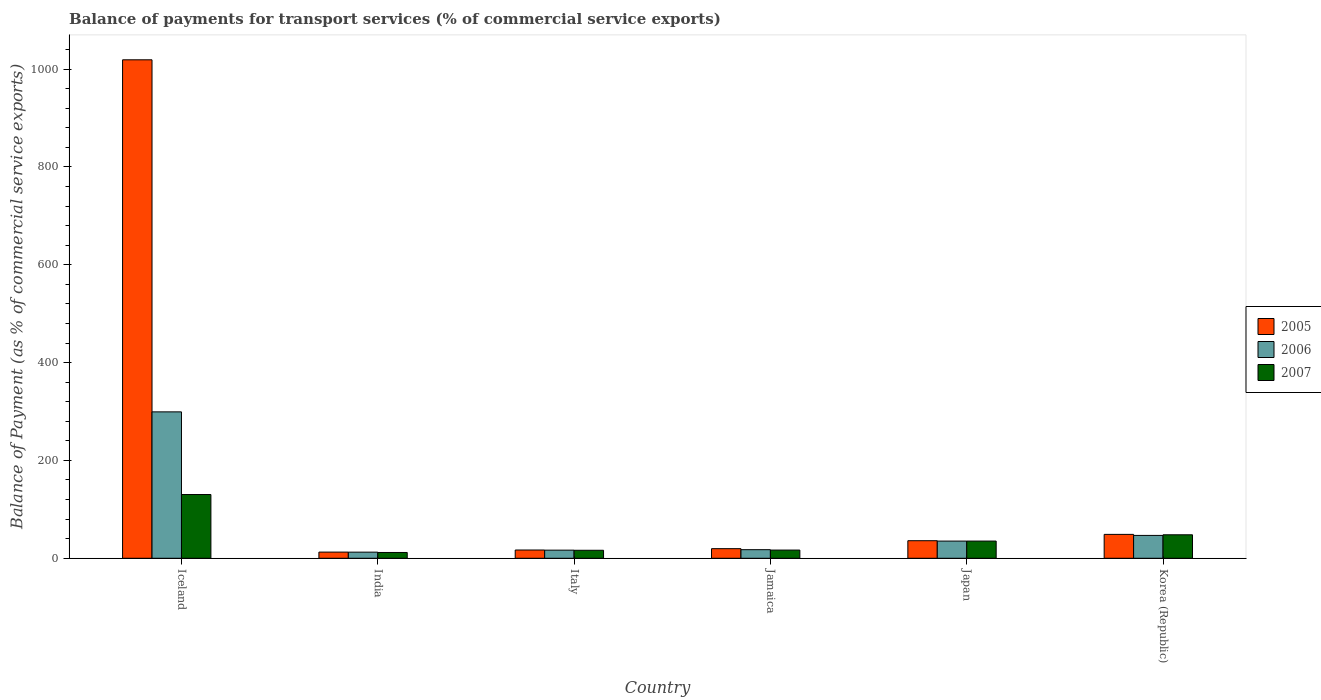How many different coloured bars are there?
Your answer should be very brief. 3. How many groups of bars are there?
Offer a terse response. 6. What is the balance of payments for transport services in 2005 in Japan?
Provide a short and direct response. 35.89. Across all countries, what is the maximum balance of payments for transport services in 2005?
Ensure brevity in your answer.  1018.95. Across all countries, what is the minimum balance of payments for transport services in 2007?
Provide a succinct answer. 11.84. In which country was the balance of payments for transport services in 2006 maximum?
Make the answer very short. Iceland. In which country was the balance of payments for transport services in 2005 minimum?
Give a very brief answer. India. What is the total balance of payments for transport services in 2005 in the graph?
Make the answer very short. 1152.83. What is the difference between the balance of payments for transport services in 2006 in India and that in Korea (Republic)?
Offer a terse response. -34.22. What is the difference between the balance of payments for transport services in 2006 in Jamaica and the balance of payments for transport services in 2005 in Korea (Republic)?
Keep it short and to the point. -31.27. What is the average balance of payments for transport services in 2007 per country?
Your answer should be very brief. 43.07. What is the difference between the balance of payments for transport services of/in 2006 and balance of payments for transport services of/in 2005 in Korea (Republic)?
Offer a very short reply. -2.11. In how many countries, is the balance of payments for transport services in 2007 greater than 880 %?
Your answer should be compact. 0. What is the ratio of the balance of payments for transport services in 2005 in Iceland to that in Korea (Republic)?
Ensure brevity in your answer.  20.86. What is the difference between the highest and the second highest balance of payments for transport services in 2005?
Provide a succinct answer. -970.12. What is the difference between the highest and the lowest balance of payments for transport services in 2007?
Your response must be concise. 118.48. In how many countries, is the balance of payments for transport services in 2006 greater than the average balance of payments for transport services in 2006 taken over all countries?
Ensure brevity in your answer.  1. Is it the case that in every country, the sum of the balance of payments for transport services in 2006 and balance of payments for transport services in 2005 is greater than the balance of payments for transport services in 2007?
Keep it short and to the point. Yes. What is the difference between two consecutive major ticks on the Y-axis?
Keep it short and to the point. 200. Are the values on the major ticks of Y-axis written in scientific E-notation?
Your answer should be very brief. No. Where does the legend appear in the graph?
Provide a short and direct response. Center right. What is the title of the graph?
Make the answer very short. Balance of payments for transport services (% of commercial service exports). Does "1969" appear as one of the legend labels in the graph?
Provide a short and direct response. No. What is the label or title of the X-axis?
Your answer should be compact. Country. What is the label or title of the Y-axis?
Ensure brevity in your answer.  Balance of Payment (as % of commercial service exports). What is the Balance of Payment (as % of commercial service exports) of 2005 in Iceland?
Your response must be concise. 1018.95. What is the Balance of Payment (as % of commercial service exports) in 2006 in Iceland?
Keep it short and to the point. 299.28. What is the Balance of Payment (as % of commercial service exports) in 2007 in Iceland?
Your response must be concise. 130.32. What is the Balance of Payment (as % of commercial service exports) in 2005 in India?
Provide a short and direct response. 12.61. What is the Balance of Payment (as % of commercial service exports) in 2006 in India?
Your answer should be very brief. 12.51. What is the Balance of Payment (as % of commercial service exports) of 2007 in India?
Your response must be concise. 11.84. What is the Balance of Payment (as % of commercial service exports) of 2005 in Italy?
Make the answer very short. 16.89. What is the Balance of Payment (as % of commercial service exports) of 2006 in Italy?
Offer a terse response. 16.59. What is the Balance of Payment (as % of commercial service exports) of 2007 in Italy?
Your response must be concise. 16.34. What is the Balance of Payment (as % of commercial service exports) of 2005 in Jamaica?
Keep it short and to the point. 19.65. What is the Balance of Payment (as % of commercial service exports) of 2006 in Jamaica?
Give a very brief answer. 17.56. What is the Balance of Payment (as % of commercial service exports) in 2007 in Jamaica?
Give a very brief answer. 16.75. What is the Balance of Payment (as % of commercial service exports) in 2005 in Japan?
Offer a terse response. 35.89. What is the Balance of Payment (as % of commercial service exports) of 2006 in Japan?
Keep it short and to the point. 35.12. What is the Balance of Payment (as % of commercial service exports) of 2007 in Japan?
Offer a very short reply. 35.16. What is the Balance of Payment (as % of commercial service exports) of 2005 in Korea (Republic)?
Your answer should be compact. 48.84. What is the Balance of Payment (as % of commercial service exports) in 2006 in Korea (Republic)?
Provide a succinct answer. 46.72. What is the Balance of Payment (as % of commercial service exports) in 2007 in Korea (Republic)?
Provide a succinct answer. 48.01. Across all countries, what is the maximum Balance of Payment (as % of commercial service exports) of 2005?
Keep it short and to the point. 1018.95. Across all countries, what is the maximum Balance of Payment (as % of commercial service exports) of 2006?
Ensure brevity in your answer.  299.28. Across all countries, what is the maximum Balance of Payment (as % of commercial service exports) in 2007?
Provide a succinct answer. 130.32. Across all countries, what is the minimum Balance of Payment (as % of commercial service exports) in 2005?
Your answer should be very brief. 12.61. Across all countries, what is the minimum Balance of Payment (as % of commercial service exports) of 2006?
Your answer should be very brief. 12.51. Across all countries, what is the minimum Balance of Payment (as % of commercial service exports) in 2007?
Give a very brief answer. 11.84. What is the total Balance of Payment (as % of commercial service exports) of 2005 in the graph?
Keep it short and to the point. 1152.83. What is the total Balance of Payment (as % of commercial service exports) of 2006 in the graph?
Provide a short and direct response. 427.78. What is the total Balance of Payment (as % of commercial service exports) of 2007 in the graph?
Provide a short and direct response. 258.42. What is the difference between the Balance of Payment (as % of commercial service exports) of 2005 in Iceland and that in India?
Ensure brevity in your answer.  1006.35. What is the difference between the Balance of Payment (as % of commercial service exports) in 2006 in Iceland and that in India?
Provide a succinct answer. 286.77. What is the difference between the Balance of Payment (as % of commercial service exports) in 2007 in Iceland and that in India?
Provide a short and direct response. 118.48. What is the difference between the Balance of Payment (as % of commercial service exports) in 2005 in Iceland and that in Italy?
Give a very brief answer. 1002.06. What is the difference between the Balance of Payment (as % of commercial service exports) of 2006 in Iceland and that in Italy?
Offer a terse response. 282.69. What is the difference between the Balance of Payment (as % of commercial service exports) in 2007 in Iceland and that in Italy?
Your response must be concise. 113.98. What is the difference between the Balance of Payment (as % of commercial service exports) in 2005 in Iceland and that in Jamaica?
Keep it short and to the point. 999.3. What is the difference between the Balance of Payment (as % of commercial service exports) of 2006 in Iceland and that in Jamaica?
Provide a succinct answer. 281.71. What is the difference between the Balance of Payment (as % of commercial service exports) in 2007 in Iceland and that in Jamaica?
Provide a succinct answer. 113.57. What is the difference between the Balance of Payment (as % of commercial service exports) in 2005 in Iceland and that in Japan?
Your answer should be compact. 983.07. What is the difference between the Balance of Payment (as % of commercial service exports) in 2006 in Iceland and that in Japan?
Your answer should be compact. 264.15. What is the difference between the Balance of Payment (as % of commercial service exports) of 2007 in Iceland and that in Japan?
Provide a short and direct response. 95.17. What is the difference between the Balance of Payment (as % of commercial service exports) of 2005 in Iceland and that in Korea (Republic)?
Keep it short and to the point. 970.12. What is the difference between the Balance of Payment (as % of commercial service exports) of 2006 in Iceland and that in Korea (Republic)?
Keep it short and to the point. 252.55. What is the difference between the Balance of Payment (as % of commercial service exports) in 2007 in Iceland and that in Korea (Republic)?
Keep it short and to the point. 82.31. What is the difference between the Balance of Payment (as % of commercial service exports) in 2005 in India and that in Italy?
Your response must be concise. -4.29. What is the difference between the Balance of Payment (as % of commercial service exports) of 2006 in India and that in Italy?
Provide a succinct answer. -4.08. What is the difference between the Balance of Payment (as % of commercial service exports) in 2007 in India and that in Italy?
Keep it short and to the point. -4.5. What is the difference between the Balance of Payment (as % of commercial service exports) of 2005 in India and that in Jamaica?
Keep it short and to the point. -7.04. What is the difference between the Balance of Payment (as % of commercial service exports) in 2006 in India and that in Jamaica?
Ensure brevity in your answer.  -5.05. What is the difference between the Balance of Payment (as % of commercial service exports) of 2007 in India and that in Jamaica?
Ensure brevity in your answer.  -4.91. What is the difference between the Balance of Payment (as % of commercial service exports) in 2005 in India and that in Japan?
Your answer should be very brief. -23.28. What is the difference between the Balance of Payment (as % of commercial service exports) of 2006 in India and that in Japan?
Offer a terse response. -22.61. What is the difference between the Balance of Payment (as % of commercial service exports) of 2007 in India and that in Japan?
Give a very brief answer. -23.32. What is the difference between the Balance of Payment (as % of commercial service exports) of 2005 in India and that in Korea (Republic)?
Offer a very short reply. -36.23. What is the difference between the Balance of Payment (as % of commercial service exports) of 2006 in India and that in Korea (Republic)?
Offer a very short reply. -34.22. What is the difference between the Balance of Payment (as % of commercial service exports) in 2007 in India and that in Korea (Republic)?
Your response must be concise. -36.17. What is the difference between the Balance of Payment (as % of commercial service exports) in 2005 in Italy and that in Jamaica?
Your answer should be very brief. -2.76. What is the difference between the Balance of Payment (as % of commercial service exports) of 2006 in Italy and that in Jamaica?
Provide a succinct answer. -0.97. What is the difference between the Balance of Payment (as % of commercial service exports) of 2007 in Italy and that in Jamaica?
Provide a succinct answer. -0.41. What is the difference between the Balance of Payment (as % of commercial service exports) of 2005 in Italy and that in Japan?
Ensure brevity in your answer.  -18.99. What is the difference between the Balance of Payment (as % of commercial service exports) of 2006 in Italy and that in Japan?
Offer a terse response. -18.53. What is the difference between the Balance of Payment (as % of commercial service exports) of 2007 in Italy and that in Japan?
Offer a terse response. -18.82. What is the difference between the Balance of Payment (as % of commercial service exports) in 2005 in Italy and that in Korea (Republic)?
Make the answer very short. -31.94. What is the difference between the Balance of Payment (as % of commercial service exports) of 2006 in Italy and that in Korea (Republic)?
Provide a succinct answer. -30.14. What is the difference between the Balance of Payment (as % of commercial service exports) of 2007 in Italy and that in Korea (Republic)?
Provide a succinct answer. -31.67. What is the difference between the Balance of Payment (as % of commercial service exports) of 2005 in Jamaica and that in Japan?
Your response must be concise. -16.24. What is the difference between the Balance of Payment (as % of commercial service exports) of 2006 in Jamaica and that in Japan?
Ensure brevity in your answer.  -17.56. What is the difference between the Balance of Payment (as % of commercial service exports) in 2007 in Jamaica and that in Japan?
Give a very brief answer. -18.41. What is the difference between the Balance of Payment (as % of commercial service exports) of 2005 in Jamaica and that in Korea (Republic)?
Your response must be concise. -29.19. What is the difference between the Balance of Payment (as % of commercial service exports) in 2006 in Jamaica and that in Korea (Republic)?
Give a very brief answer. -29.16. What is the difference between the Balance of Payment (as % of commercial service exports) of 2007 in Jamaica and that in Korea (Republic)?
Your response must be concise. -31.26. What is the difference between the Balance of Payment (as % of commercial service exports) in 2005 in Japan and that in Korea (Republic)?
Make the answer very short. -12.95. What is the difference between the Balance of Payment (as % of commercial service exports) of 2006 in Japan and that in Korea (Republic)?
Provide a succinct answer. -11.6. What is the difference between the Balance of Payment (as % of commercial service exports) of 2007 in Japan and that in Korea (Republic)?
Provide a short and direct response. -12.85. What is the difference between the Balance of Payment (as % of commercial service exports) of 2005 in Iceland and the Balance of Payment (as % of commercial service exports) of 2006 in India?
Ensure brevity in your answer.  1006.44. What is the difference between the Balance of Payment (as % of commercial service exports) in 2005 in Iceland and the Balance of Payment (as % of commercial service exports) in 2007 in India?
Your response must be concise. 1007.11. What is the difference between the Balance of Payment (as % of commercial service exports) of 2006 in Iceland and the Balance of Payment (as % of commercial service exports) of 2007 in India?
Keep it short and to the point. 287.44. What is the difference between the Balance of Payment (as % of commercial service exports) of 2005 in Iceland and the Balance of Payment (as % of commercial service exports) of 2006 in Italy?
Keep it short and to the point. 1002.36. What is the difference between the Balance of Payment (as % of commercial service exports) of 2005 in Iceland and the Balance of Payment (as % of commercial service exports) of 2007 in Italy?
Ensure brevity in your answer.  1002.61. What is the difference between the Balance of Payment (as % of commercial service exports) of 2006 in Iceland and the Balance of Payment (as % of commercial service exports) of 2007 in Italy?
Provide a short and direct response. 282.94. What is the difference between the Balance of Payment (as % of commercial service exports) in 2005 in Iceland and the Balance of Payment (as % of commercial service exports) in 2006 in Jamaica?
Provide a short and direct response. 1001.39. What is the difference between the Balance of Payment (as % of commercial service exports) in 2005 in Iceland and the Balance of Payment (as % of commercial service exports) in 2007 in Jamaica?
Ensure brevity in your answer.  1002.2. What is the difference between the Balance of Payment (as % of commercial service exports) of 2006 in Iceland and the Balance of Payment (as % of commercial service exports) of 2007 in Jamaica?
Make the answer very short. 282.53. What is the difference between the Balance of Payment (as % of commercial service exports) of 2005 in Iceland and the Balance of Payment (as % of commercial service exports) of 2006 in Japan?
Your answer should be compact. 983.83. What is the difference between the Balance of Payment (as % of commercial service exports) of 2005 in Iceland and the Balance of Payment (as % of commercial service exports) of 2007 in Japan?
Offer a very short reply. 983.8. What is the difference between the Balance of Payment (as % of commercial service exports) in 2006 in Iceland and the Balance of Payment (as % of commercial service exports) in 2007 in Japan?
Your answer should be very brief. 264.12. What is the difference between the Balance of Payment (as % of commercial service exports) of 2005 in Iceland and the Balance of Payment (as % of commercial service exports) of 2006 in Korea (Republic)?
Keep it short and to the point. 972.23. What is the difference between the Balance of Payment (as % of commercial service exports) of 2005 in Iceland and the Balance of Payment (as % of commercial service exports) of 2007 in Korea (Republic)?
Ensure brevity in your answer.  970.94. What is the difference between the Balance of Payment (as % of commercial service exports) of 2006 in Iceland and the Balance of Payment (as % of commercial service exports) of 2007 in Korea (Republic)?
Offer a very short reply. 251.27. What is the difference between the Balance of Payment (as % of commercial service exports) in 2005 in India and the Balance of Payment (as % of commercial service exports) in 2006 in Italy?
Ensure brevity in your answer.  -3.98. What is the difference between the Balance of Payment (as % of commercial service exports) in 2005 in India and the Balance of Payment (as % of commercial service exports) in 2007 in Italy?
Provide a succinct answer. -3.73. What is the difference between the Balance of Payment (as % of commercial service exports) of 2006 in India and the Balance of Payment (as % of commercial service exports) of 2007 in Italy?
Make the answer very short. -3.83. What is the difference between the Balance of Payment (as % of commercial service exports) in 2005 in India and the Balance of Payment (as % of commercial service exports) in 2006 in Jamaica?
Your answer should be compact. -4.95. What is the difference between the Balance of Payment (as % of commercial service exports) of 2005 in India and the Balance of Payment (as % of commercial service exports) of 2007 in Jamaica?
Offer a very short reply. -4.14. What is the difference between the Balance of Payment (as % of commercial service exports) of 2006 in India and the Balance of Payment (as % of commercial service exports) of 2007 in Jamaica?
Provide a succinct answer. -4.24. What is the difference between the Balance of Payment (as % of commercial service exports) in 2005 in India and the Balance of Payment (as % of commercial service exports) in 2006 in Japan?
Keep it short and to the point. -22.52. What is the difference between the Balance of Payment (as % of commercial service exports) in 2005 in India and the Balance of Payment (as % of commercial service exports) in 2007 in Japan?
Offer a very short reply. -22.55. What is the difference between the Balance of Payment (as % of commercial service exports) in 2006 in India and the Balance of Payment (as % of commercial service exports) in 2007 in Japan?
Offer a very short reply. -22.65. What is the difference between the Balance of Payment (as % of commercial service exports) of 2005 in India and the Balance of Payment (as % of commercial service exports) of 2006 in Korea (Republic)?
Make the answer very short. -34.12. What is the difference between the Balance of Payment (as % of commercial service exports) in 2005 in India and the Balance of Payment (as % of commercial service exports) in 2007 in Korea (Republic)?
Offer a terse response. -35.4. What is the difference between the Balance of Payment (as % of commercial service exports) in 2006 in India and the Balance of Payment (as % of commercial service exports) in 2007 in Korea (Republic)?
Your answer should be very brief. -35.5. What is the difference between the Balance of Payment (as % of commercial service exports) of 2005 in Italy and the Balance of Payment (as % of commercial service exports) of 2006 in Jamaica?
Your answer should be compact. -0.67. What is the difference between the Balance of Payment (as % of commercial service exports) in 2005 in Italy and the Balance of Payment (as % of commercial service exports) in 2007 in Jamaica?
Provide a short and direct response. 0.14. What is the difference between the Balance of Payment (as % of commercial service exports) in 2006 in Italy and the Balance of Payment (as % of commercial service exports) in 2007 in Jamaica?
Give a very brief answer. -0.16. What is the difference between the Balance of Payment (as % of commercial service exports) in 2005 in Italy and the Balance of Payment (as % of commercial service exports) in 2006 in Japan?
Offer a very short reply. -18.23. What is the difference between the Balance of Payment (as % of commercial service exports) of 2005 in Italy and the Balance of Payment (as % of commercial service exports) of 2007 in Japan?
Make the answer very short. -18.26. What is the difference between the Balance of Payment (as % of commercial service exports) of 2006 in Italy and the Balance of Payment (as % of commercial service exports) of 2007 in Japan?
Keep it short and to the point. -18.57. What is the difference between the Balance of Payment (as % of commercial service exports) in 2005 in Italy and the Balance of Payment (as % of commercial service exports) in 2006 in Korea (Republic)?
Offer a terse response. -29.83. What is the difference between the Balance of Payment (as % of commercial service exports) in 2005 in Italy and the Balance of Payment (as % of commercial service exports) in 2007 in Korea (Republic)?
Offer a terse response. -31.12. What is the difference between the Balance of Payment (as % of commercial service exports) of 2006 in Italy and the Balance of Payment (as % of commercial service exports) of 2007 in Korea (Republic)?
Give a very brief answer. -31.42. What is the difference between the Balance of Payment (as % of commercial service exports) in 2005 in Jamaica and the Balance of Payment (as % of commercial service exports) in 2006 in Japan?
Offer a very short reply. -15.47. What is the difference between the Balance of Payment (as % of commercial service exports) of 2005 in Jamaica and the Balance of Payment (as % of commercial service exports) of 2007 in Japan?
Your answer should be very brief. -15.51. What is the difference between the Balance of Payment (as % of commercial service exports) of 2006 in Jamaica and the Balance of Payment (as % of commercial service exports) of 2007 in Japan?
Ensure brevity in your answer.  -17.6. What is the difference between the Balance of Payment (as % of commercial service exports) in 2005 in Jamaica and the Balance of Payment (as % of commercial service exports) in 2006 in Korea (Republic)?
Make the answer very short. -27.07. What is the difference between the Balance of Payment (as % of commercial service exports) of 2005 in Jamaica and the Balance of Payment (as % of commercial service exports) of 2007 in Korea (Republic)?
Your answer should be compact. -28.36. What is the difference between the Balance of Payment (as % of commercial service exports) in 2006 in Jamaica and the Balance of Payment (as % of commercial service exports) in 2007 in Korea (Republic)?
Give a very brief answer. -30.45. What is the difference between the Balance of Payment (as % of commercial service exports) of 2005 in Japan and the Balance of Payment (as % of commercial service exports) of 2006 in Korea (Republic)?
Provide a succinct answer. -10.84. What is the difference between the Balance of Payment (as % of commercial service exports) of 2005 in Japan and the Balance of Payment (as % of commercial service exports) of 2007 in Korea (Republic)?
Provide a short and direct response. -12.12. What is the difference between the Balance of Payment (as % of commercial service exports) of 2006 in Japan and the Balance of Payment (as % of commercial service exports) of 2007 in Korea (Republic)?
Make the answer very short. -12.89. What is the average Balance of Payment (as % of commercial service exports) of 2005 per country?
Ensure brevity in your answer.  192.14. What is the average Balance of Payment (as % of commercial service exports) of 2006 per country?
Offer a terse response. 71.3. What is the average Balance of Payment (as % of commercial service exports) in 2007 per country?
Provide a succinct answer. 43.07. What is the difference between the Balance of Payment (as % of commercial service exports) in 2005 and Balance of Payment (as % of commercial service exports) in 2006 in Iceland?
Provide a succinct answer. 719.68. What is the difference between the Balance of Payment (as % of commercial service exports) in 2005 and Balance of Payment (as % of commercial service exports) in 2007 in Iceland?
Offer a very short reply. 888.63. What is the difference between the Balance of Payment (as % of commercial service exports) of 2006 and Balance of Payment (as % of commercial service exports) of 2007 in Iceland?
Provide a succinct answer. 168.95. What is the difference between the Balance of Payment (as % of commercial service exports) of 2005 and Balance of Payment (as % of commercial service exports) of 2006 in India?
Provide a short and direct response. 0.1. What is the difference between the Balance of Payment (as % of commercial service exports) in 2005 and Balance of Payment (as % of commercial service exports) in 2007 in India?
Your response must be concise. 0.77. What is the difference between the Balance of Payment (as % of commercial service exports) in 2006 and Balance of Payment (as % of commercial service exports) in 2007 in India?
Your answer should be compact. 0.67. What is the difference between the Balance of Payment (as % of commercial service exports) of 2005 and Balance of Payment (as % of commercial service exports) of 2006 in Italy?
Provide a short and direct response. 0.31. What is the difference between the Balance of Payment (as % of commercial service exports) in 2005 and Balance of Payment (as % of commercial service exports) in 2007 in Italy?
Provide a short and direct response. 0.55. What is the difference between the Balance of Payment (as % of commercial service exports) of 2006 and Balance of Payment (as % of commercial service exports) of 2007 in Italy?
Ensure brevity in your answer.  0.25. What is the difference between the Balance of Payment (as % of commercial service exports) of 2005 and Balance of Payment (as % of commercial service exports) of 2006 in Jamaica?
Your response must be concise. 2.09. What is the difference between the Balance of Payment (as % of commercial service exports) in 2005 and Balance of Payment (as % of commercial service exports) in 2007 in Jamaica?
Your response must be concise. 2.9. What is the difference between the Balance of Payment (as % of commercial service exports) of 2006 and Balance of Payment (as % of commercial service exports) of 2007 in Jamaica?
Give a very brief answer. 0.81. What is the difference between the Balance of Payment (as % of commercial service exports) of 2005 and Balance of Payment (as % of commercial service exports) of 2006 in Japan?
Your response must be concise. 0.76. What is the difference between the Balance of Payment (as % of commercial service exports) in 2005 and Balance of Payment (as % of commercial service exports) in 2007 in Japan?
Provide a short and direct response. 0.73. What is the difference between the Balance of Payment (as % of commercial service exports) in 2006 and Balance of Payment (as % of commercial service exports) in 2007 in Japan?
Give a very brief answer. -0.03. What is the difference between the Balance of Payment (as % of commercial service exports) of 2005 and Balance of Payment (as % of commercial service exports) of 2006 in Korea (Republic)?
Ensure brevity in your answer.  2.11. What is the difference between the Balance of Payment (as % of commercial service exports) in 2005 and Balance of Payment (as % of commercial service exports) in 2007 in Korea (Republic)?
Keep it short and to the point. 0.83. What is the difference between the Balance of Payment (as % of commercial service exports) in 2006 and Balance of Payment (as % of commercial service exports) in 2007 in Korea (Republic)?
Provide a short and direct response. -1.29. What is the ratio of the Balance of Payment (as % of commercial service exports) of 2005 in Iceland to that in India?
Your response must be concise. 80.82. What is the ratio of the Balance of Payment (as % of commercial service exports) in 2006 in Iceland to that in India?
Your answer should be compact. 23.93. What is the ratio of the Balance of Payment (as % of commercial service exports) of 2007 in Iceland to that in India?
Make the answer very short. 11.01. What is the ratio of the Balance of Payment (as % of commercial service exports) in 2005 in Iceland to that in Italy?
Your answer should be compact. 60.31. What is the ratio of the Balance of Payment (as % of commercial service exports) in 2006 in Iceland to that in Italy?
Give a very brief answer. 18.04. What is the ratio of the Balance of Payment (as % of commercial service exports) of 2007 in Iceland to that in Italy?
Your response must be concise. 7.98. What is the ratio of the Balance of Payment (as % of commercial service exports) in 2005 in Iceland to that in Jamaica?
Offer a terse response. 51.85. What is the ratio of the Balance of Payment (as % of commercial service exports) of 2006 in Iceland to that in Jamaica?
Your answer should be compact. 17.04. What is the ratio of the Balance of Payment (as % of commercial service exports) of 2007 in Iceland to that in Jamaica?
Keep it short and to the point. 7.78. What is the ratio of the Balance of Payment (as % of commercial service exports) of 2005 in Iceland to that in Japan?
Your answer should be very brief. 28.39. What is the ratio of the Balance of Payment (as % of commercial service exports) in 2006 in Iceland to that in Japan?
Provide a succinct answer. 8.52. What is the ratio of the Balance of Payment (as % of commercial service exports) in 2007 in Iceland to that in Japan?
Offer a terse response. 3.71. What is the ratio of the Balance of Payment (as % of commercial service exports) of 2005 in Iceland to that in Korea (Republic)?
Make the answer very short. 20.86. What is the ratio of the Balance of Payment (as % of commercial service exports) of 2006 in Iceland to that in Korea (Republic)?
Ensure brevity in your answer.  6.41. What is the ratio of the Balance of Payment (as % of commercial service exports) in 2007 in Iceland to that in Korea (Republic)?
Provide a succinct answer. 2.71. What is the ratio of the Balance of Payment (as % of commercial service exports) in 2005 in India to that in Italy?
Your answer should be very brief. 0.75. What is the ratio of the Balance of Payment (as % of commercial service exports) of 2006 in India to that in Italy?
Offer a terse response. 0.75. What is the ratio of the Balance of Payment (as % of commercial service exports) in 2007 in India to that in Italy?
Your response must be concise. 0.72. What is the ratio of the Balance of Payment (as % of commercial service exports) of 2005 in India to that in Jamaica?
Your answer should be compact. 0.64. What is the ratio of the Balance of Payment (as % of commercial service exports) in 2006 in India to that in Jamaica?
Make the answer very short. 0.71. What is the ratio of the Balance of Payment (as % of commercial service exports) of 2007 in India to that in Jamaica?
Give a very brief answer. 0.71. What is the ratio of the Balance of Payment (as % of commercial service exports) of 2005 in India to that in Japan?
Make the answer very short. 0.35. What is the ratio of the Balance of Payment (as % of commercial service exports) of 2006 in India to that in Japan?
Ensure brevity in your answer.  0.36. What is the ratio of the Balance of Payment (as % of commercial service exports) of 2007 in India to that in Japan?
Offer a very short reply. 0.34. What is the ratio of the Balance of Payment (as % of commercial service exports) in 2005 in India to that in Korea (Republic)?
Your answer should be compact. 0.26. What is the ratio of the Balance of Payment (as % of commercial service exports) in 2006 in India to that in Korea (Republic)?
Your response must be concise. 0.27. What is the ratio of the Balance of Payment (as % of commercial service exports) in 2007 in India to that in Korea (Republic)?
Your answer should be very brief. 0.25. What is the ratio of the Balance of Payment (as % of commercial service exports) in 2005 in Italy to that in Jamaica?
Keep it short and to the point. 0.86. What is the ratio of the Balance of Payment (as % of commercial service exports) of 2006 in Italy to that in Jamaica?
Make the answer very short. 0.94. What is the ratio of the Balance of Payment (as % of commercial service exports) in 2007 in Italy to that in Jamaica?
Your answer should be compact. 0.98. What is the ratio of the Balance of Payment (as % of commercial service exports) of 2005 in Italy to that in Japan?
Your answer should be compact. 0.47. What is the ratio of the Balance of Payment (as % of commercial service exports) in 2006 in Italy to that in Japan?
Your answer should be very brief. 0.47. What is the ratio of the Balance of Payment (as % of commercial service exports) of 2007 in Italy to that in Japan?
Provide a succinct answer. 0.46. What is the ratio of the Balance of Payment (as % of commercial service exports) in 2005 in Italy to that in Korea (Republic)?
Your response must be concise. 0.35. What is the ratio of the Balance of Payment (as % of commercial service exports) in 2006 in Italy to that in Korea (Republic)?
Provide a short and direct response. 0.35. What is the ratio of the Balance of Payment (as % of commercial service exports) of 2007 in Italy to that in Korea (Republic)?
Make the answer very short. 0.34. What is the ratio of the Balance of Payment (as % of commercial service exports) of 2005 in Jamaica to that in Japan?
Your response must be concise. 0.55. What is the ratio of the Balance of Payment (as % of commercial service exports) of 2006 in Jamaica to that in Japan?
Keep it short and to the point. 0.5. What is the ratio of the Balance of Payment (as % of commercial service exports) in 2007 in Jamaica to that in Japan?
Make the answer very short. 0.48. What is the ratio of the Balance of Payment (as % of commercial service exports) in 2005 in Jamaica to that in Korea (Republic)?
Your answer should be compact. 0.4. What is the ratio of the Balance of Payment (as % of commercial service exports) of 2006 in Jamaica to that in Korea (Republic)?
Ensure brevity in your answer.  0.38. What is the ratio of the Balance of Payment (as % of commercial service exports) in 2007 in Jamaica to that in Korea (Republic)?
Ensure brevity in your answer.  0.35. What is the ratio of the Balance of Payment (as % of commercial service exports) of 2005 in Japan to that in Korea (Republic)?
Your response must be concise. 0.73. What is the ratio of the Balance of Payment (as % of commercial service exports) in 2006 in Japan to that in Korea (Republic)?
Your answer should be very brief. 0.75. What is the ratio of the Balance of Payment (as % of commercial service exports) of 2007 in Japan to that in Korea (Republic)?
Offer a terse response. 0.73. What is the difference between the highest and the second highest Balance of Payment (as % of commercial service exports) in 2005?
Keep it short and to the point. 970.12. What is the difference between the highest and the second highest Balance of Payment (as % of commercial service exports) of 2006?
Offer a terse response. 252.55. What is the difference between the highest and the second highest Balance of Payment (as % of commercial service exports) in 2007?
Offer a very short reply. 82.31. What is the difference between the highest and the lowest Balance of Payment (as % of commercial service exports) in 2005?
Your response must be concise. 1006.35. What is the difference between the highest and the lowest Balance of Payment (as % of commercial service exports) of 2006?
Keep it short and to the point. 286.77. What is the difference between the highest and the lowest Balance of Payment (as % of commercial service exports) in 2007?
Your response must be concise. 118.48. 